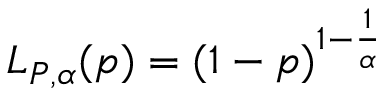Convert formula to latex. <formula><loc_0><loc_0><loc_500><loc_500>L _ { P , \alpha } ( p ) = ( 1 - p ) ^ { 1 - \frac { 1 } { \alpha } }</formula> 